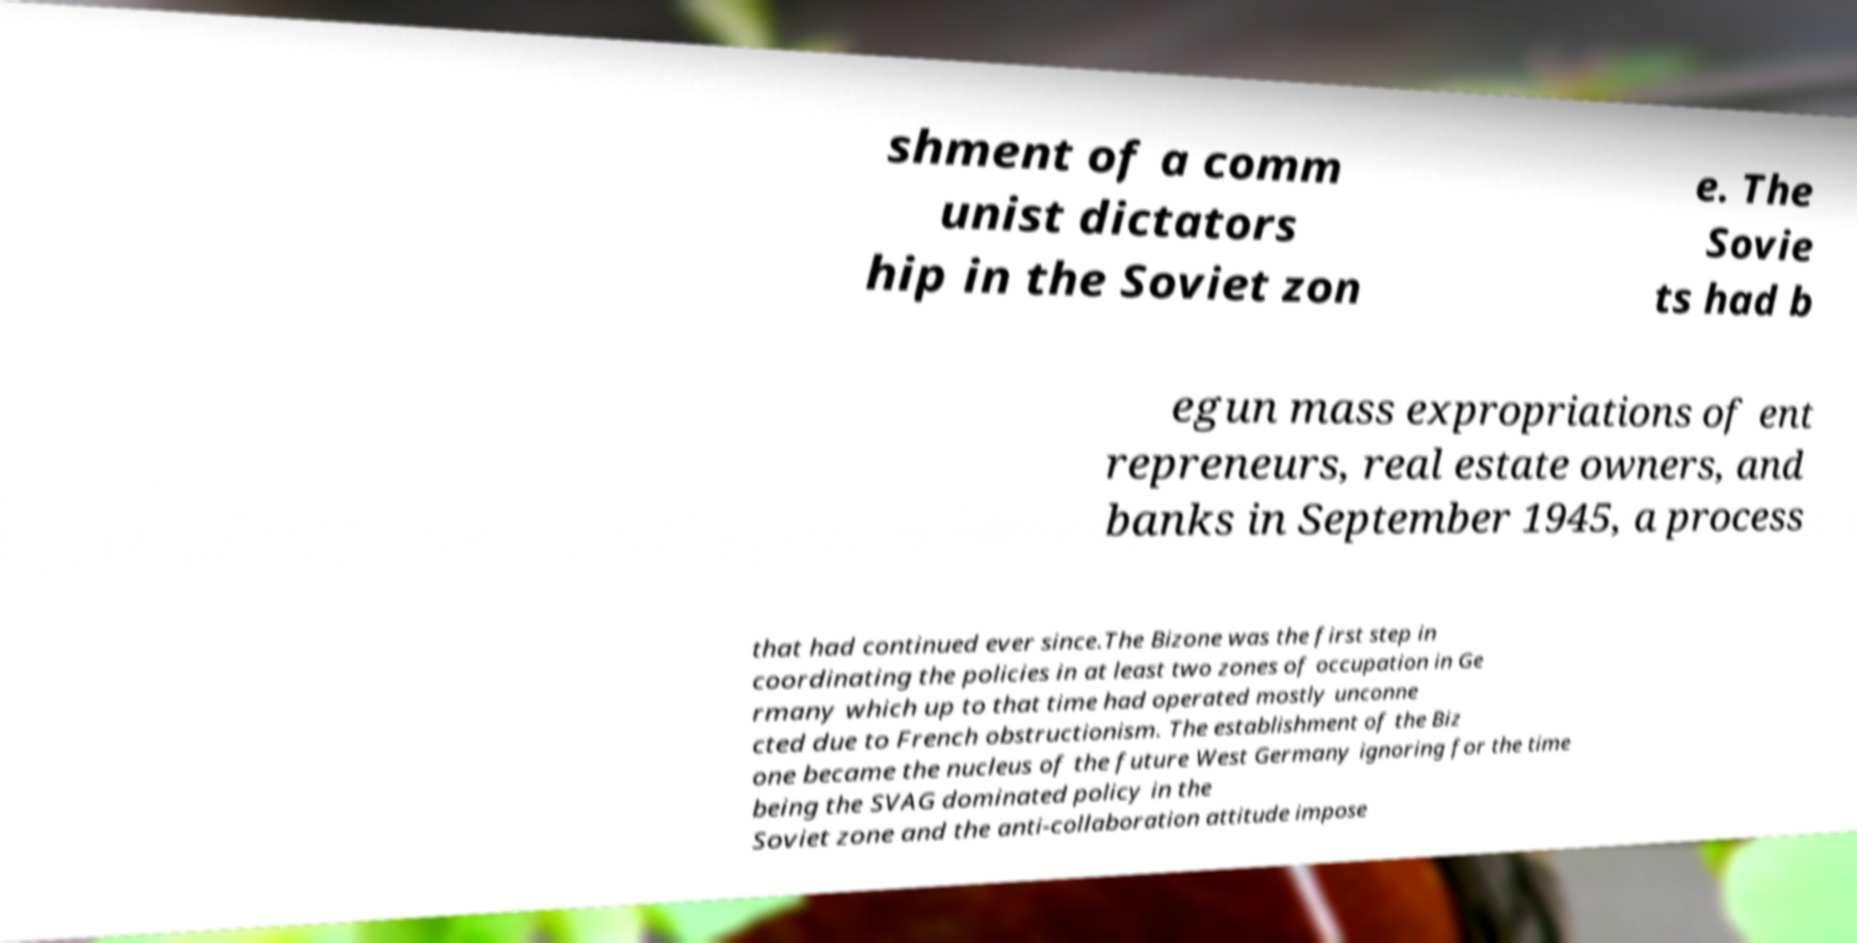Could you assist in decoding the text presented in this image and type it out clearly? shment of a comm unist dictators hip in the Soviet zon e. The Sovie ts had b egun mass expropriations of ent repreneurs, real estate owners, and banks in September 1945, a process that had continued ever since.The Bizone was the first step in coordinating the policies in at least two zones of occupation in Ge rmany which up to that time had operated mostly unconne cted due to French obstructionism. The establishment of the Biz one became the nucleus of the future West Germany ignoring for the time being the SVAG dominated policy in the Soviet zone and the anti-collaboration attitude impose 